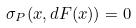Convert formula to latex. <formula><loc_0><loc_0><loc_500><loc_500>\sigma _ { P } ( x , d F ( x ) ) = 0</formula> 